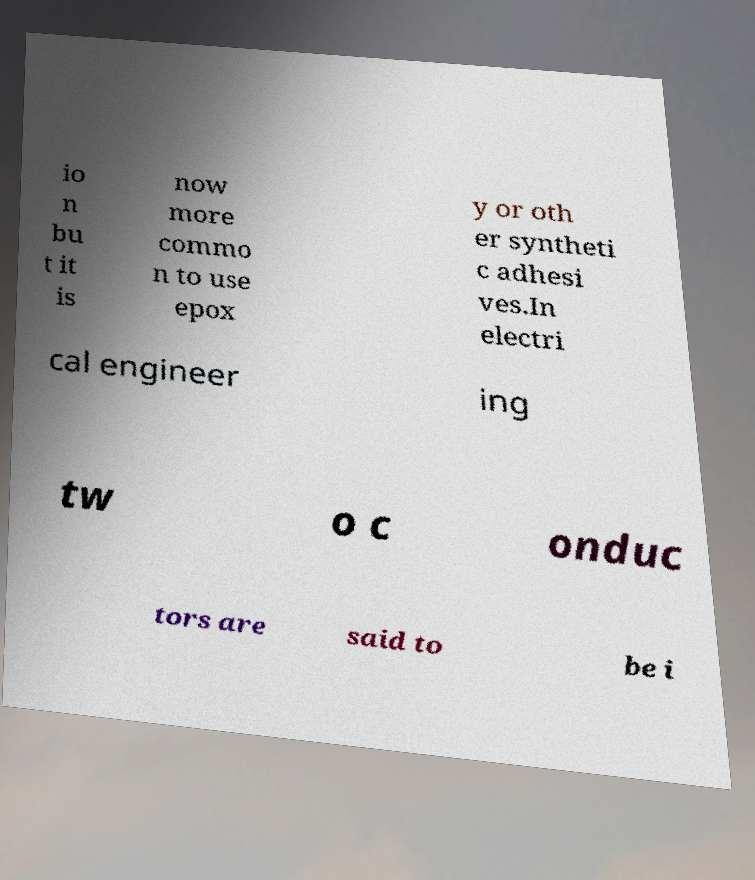There's text embedded in this image that I need extracted. Can you transcribe it verbatim? io n bu t it is now more commo n to use epox y or oth er syntheti c adhesi ves.In electri cal engineer ing tw o c onduc tors are said to be i 